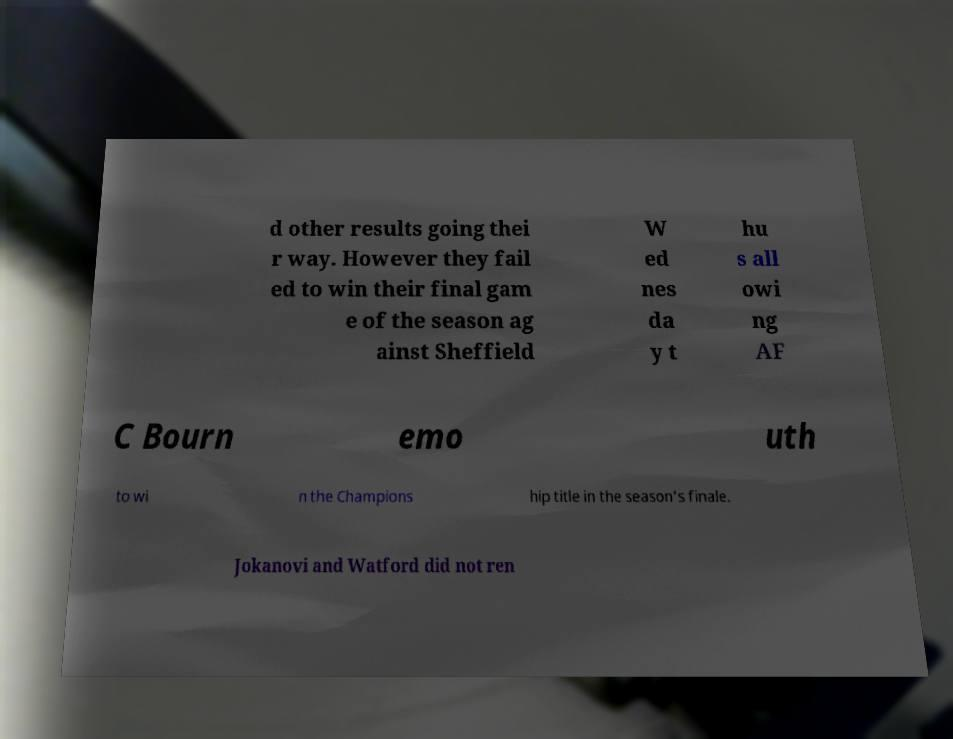Can you read and provide the text displayed in the image?This photo seems to have some interesting text. Can you extract and type it out for me? d other results going thei r way. However they fail ed to win their final gam e of the season ag ainst Sheffield W ed nes da y t hu s all owi ng AF C Bourn emo uth to wi n the Champions hip title in the season's finale. Jokanovi and Watford did not ren 